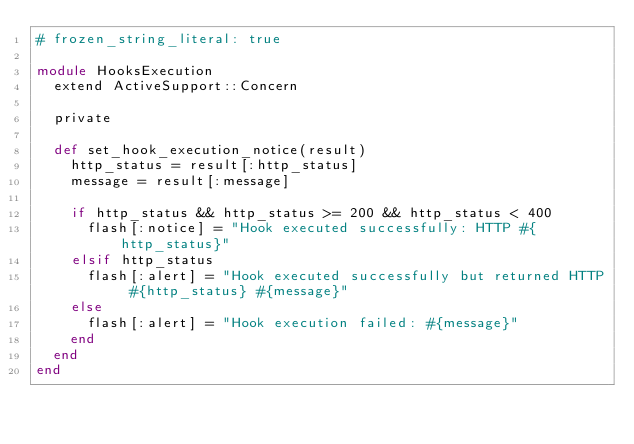Convert code to text. <code><loc_0><loc_0><loc_500><loc_500><_Ruby_># frozen_string_literal: true

module HooksExecution
  extend ActiveSupport::Concern

  private

  def set_hook_execution_notice(result)
    http_status = result[:http_status]
    message = result[:message]

    if http_status && http_status >= 200 && http_status < 400
      flash[:notice] = "Hook executed successfully: HTTP #{http_status}"
    elsif http_status
      flash[:alert] = "Hook executed successfully but returned HTTP #{http_status} #{message}"
    else
      flash[:alert] = "Hook execution failed: #{message}"
    end
  end
end
</code> 